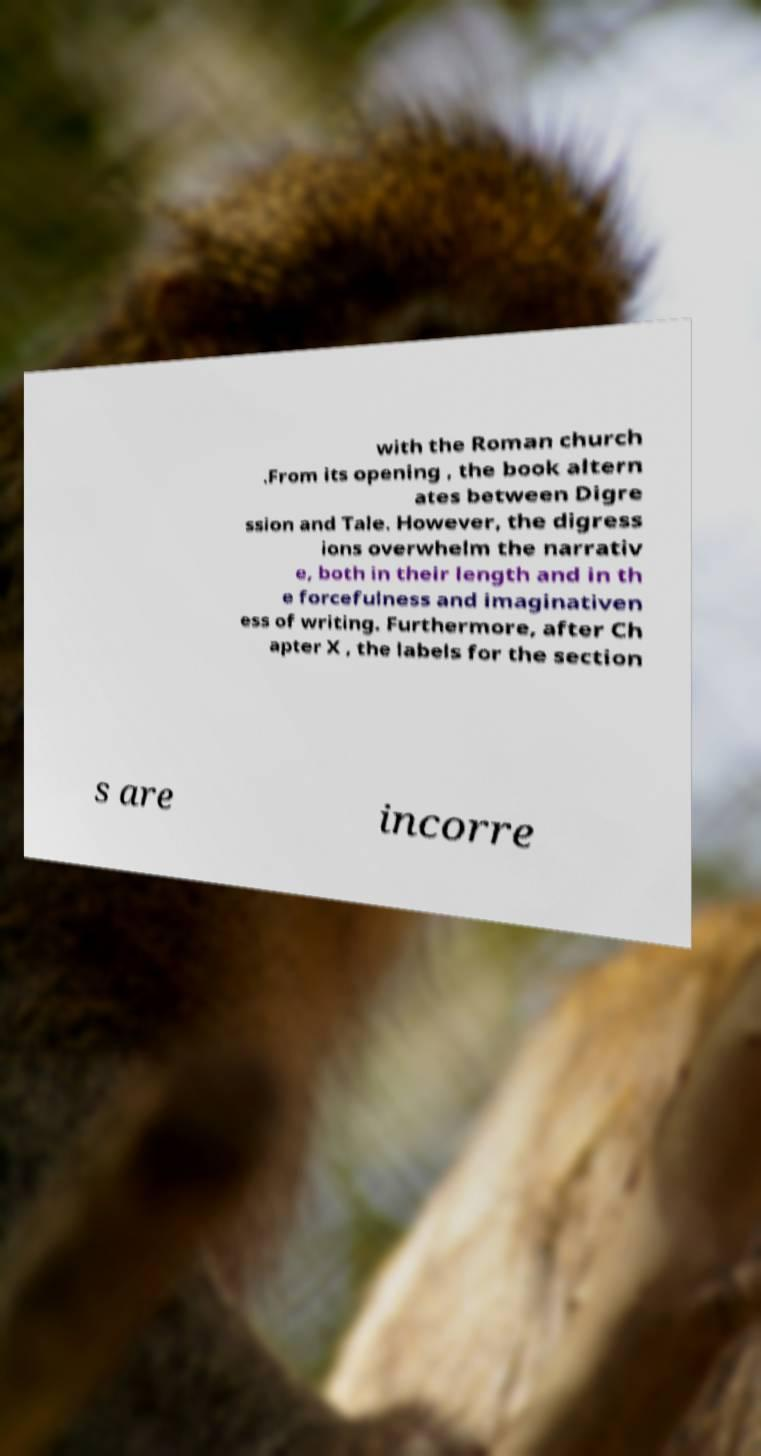Could you assist in decoding the text presented in this image and type it out clearly? with the Roman church .From its opening , the book altern ates between Digre ssion and Tale. However, the digress ions overwhelm the narrativ e, both in their length and in th e forcefulness and imaginativen ess of writing. Furthermore, after Ch apter X , the labels for the section s are incorre 